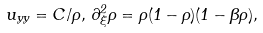<formula> <loc_0><loc_0><loc_500><loc_500>u _ { y y } = C / \rho , \, \partial _ { \xi } ^ { 2 } \rho = \rho ( 1 - \rho ) ( 1 - \beta \rho ) ,</formula> 